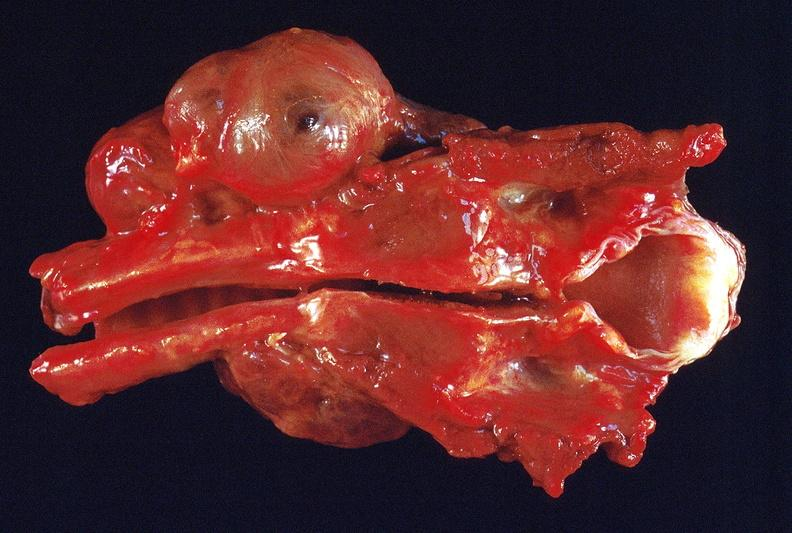s endocrine present?
Answer the question using a single word or phrase. Yes 